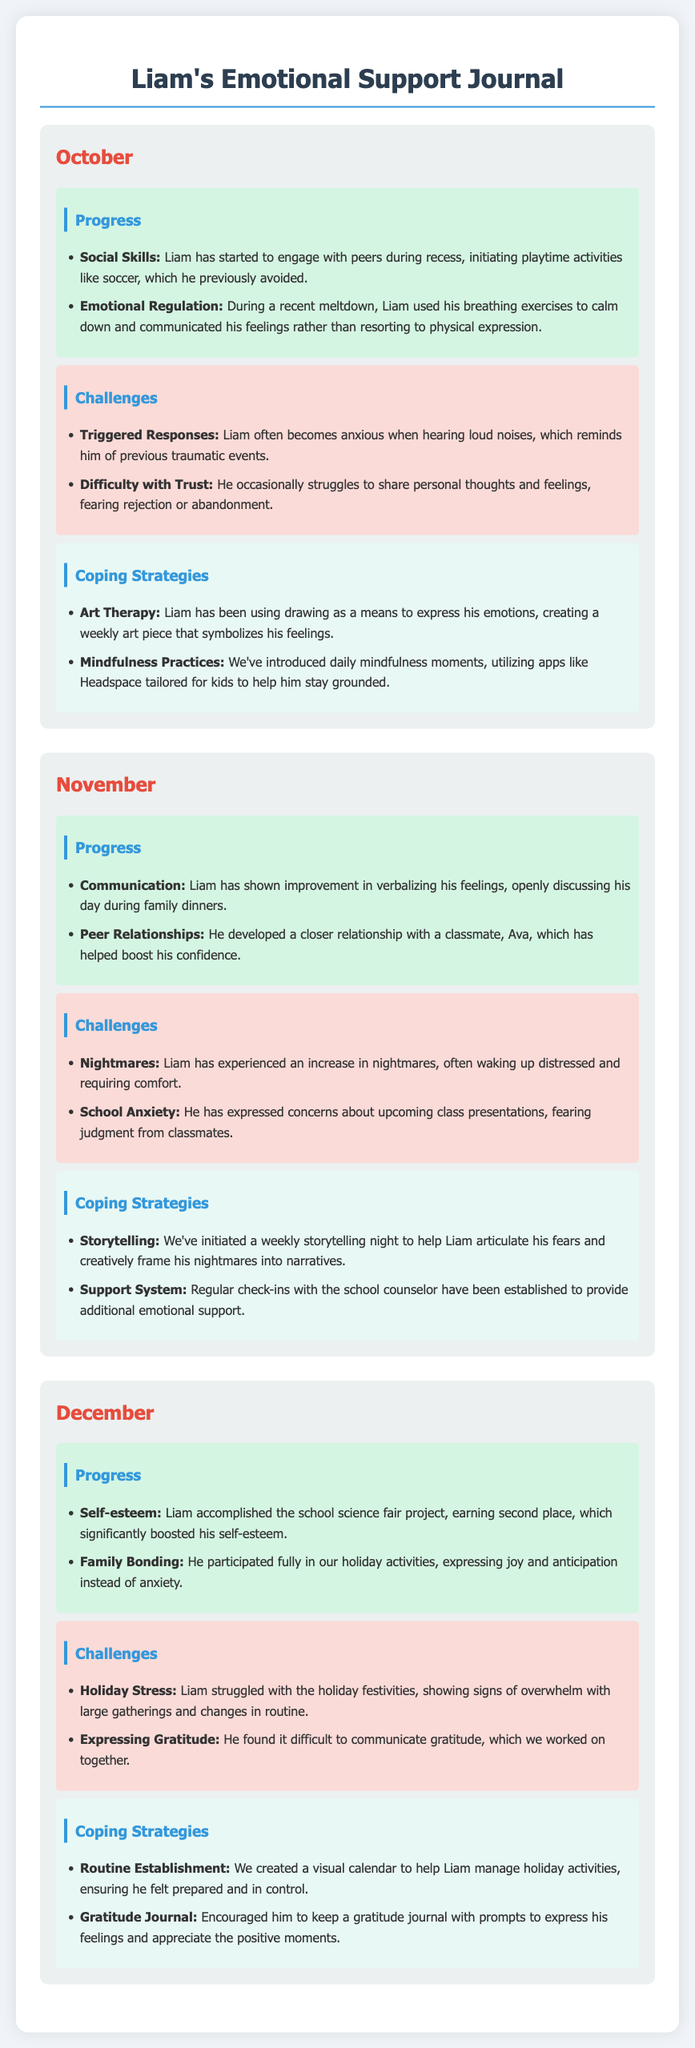what is the name of the child in the journal? The journal focuses on the experiences and developments of a child named Liam.
Answer: Liam what month is documented after November? The entries are documented in chronological order, the month that follows November is December.
Answer: December which coping strategy involves expressing emotions through art? The document mentions that Liam uses drawing as a means to express his emotions.
Answer: Art Therapy how did Liam’s self-esteem change in December? In December, Liam accomplished a project that significantly boosted his self-esteem, earning second place in the school science fair.
Answer: Boosted what specific fears does Liam express related to school? Liam has fears about upcoming class presentations, worrying about judgment from classmates.
Answer: Judgment in how many months is Liam’s progress reported? The journal records his progress, challenges, and coping strategies across three months: October, November, and December.
Answer: Three months what color indicates the section for challenges in the journal? The challenges section is distinguished by a background color that is light pinkish (described in the document as #fadbd8).
Answer: Light pinkish which coping strategy was introduced to help Liam manage holiday activities? A visual calendar was created to assist Liam in managing holiday activities, ensuring he felt prepared.
Answer: Routine Establishment how many specific coping strategies are listed for November? In November, the journal lists two specific coping strategies that were initiated for Liam.
Answer: Two 